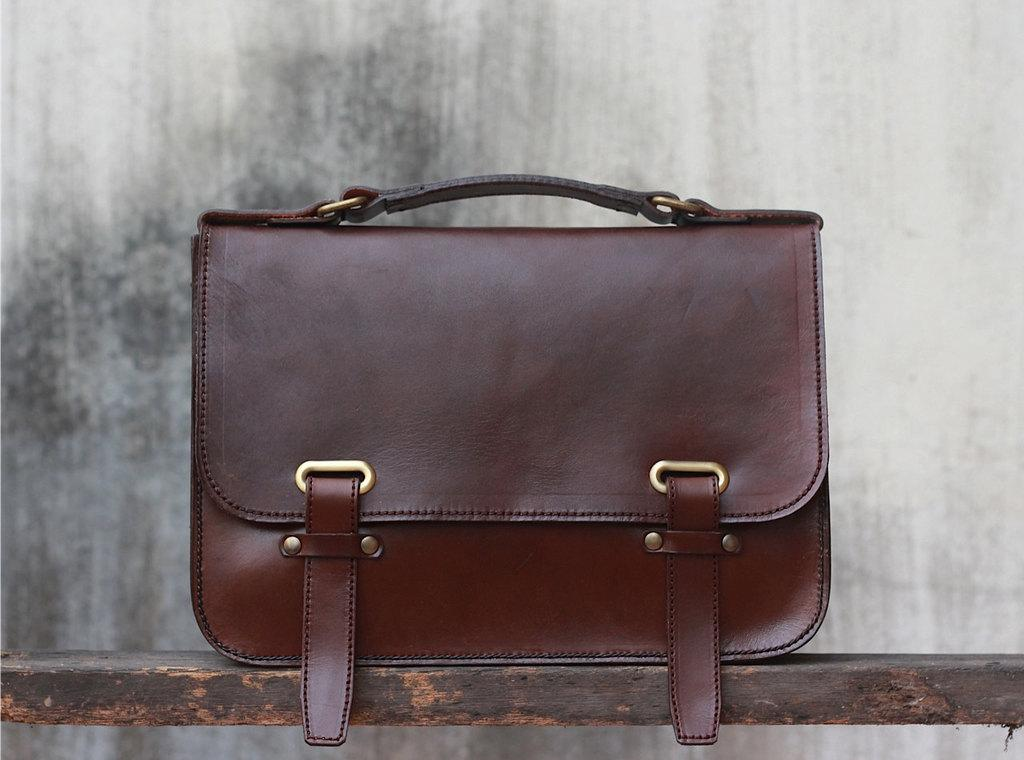What type of item is the main subject of the image? The main subject of the image is a handbag. What feature is present on the handbag for carrying it? The handbag has a handle for carrying it. What additional feature is present on the handbag? The handbag has a hook. What material is the handbag made of? The handbag is made of leather. Where is the handbag located in the image? The handbag is on a wooden rack in the image. What type of lip can be seen on the tray in the image? There is no tray or lip present in the image; it features a handbag on a wooden rack. 